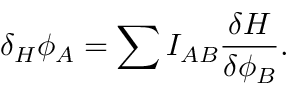Convert formula to latex. <formula><loc_0><loc_0><loc_500><loc_500>\delta _ { H } \phi _ { A } = \sum I _ { A B } { \frac { \delta H } { \delta \phi _ { B } } } .</formula> 